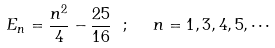<formula> <loc_0><loc_0><loc_500><loc_500>E _ { n } = \frac { n ^ { 2 } } { 4 } - \frac { 2 5 } { 1 6 } \text { } ; \text { \ } n = 1 , 3 , 4 , 5 , \cdots</formula> 